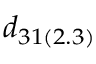<formula> <loc_0><loc_0><loc_500><loc_500>d _ { 3 1 ( 2 . 3 ) }</formula> 